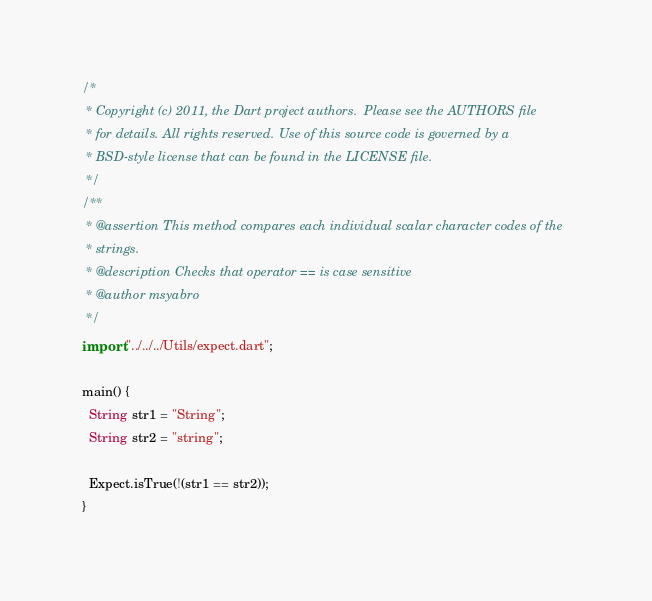Convert code to text. <code><loc_0><loc_0><loc_500><loc_500><_Dart_>/*
 * Copyright (c) 2011, the Dart project authors.  Please see the AUTHORS file
 * for details. All rights reserved. Use of this source code is governed by a
 * BSD-style license that can be found in the LICENSE file.
 */
/**
 * @assertion This method compares each individual scalar character codes of the
 * strings.
 * @description Checks that operator == is case sensitive
 * @author msyabro
 */
import "../../../Utils/expect.dart";

main() {
  String str1 = "String";
  String str2 = "string";

  Expect.isTrue(!(str1 == str2));
}
</code> 